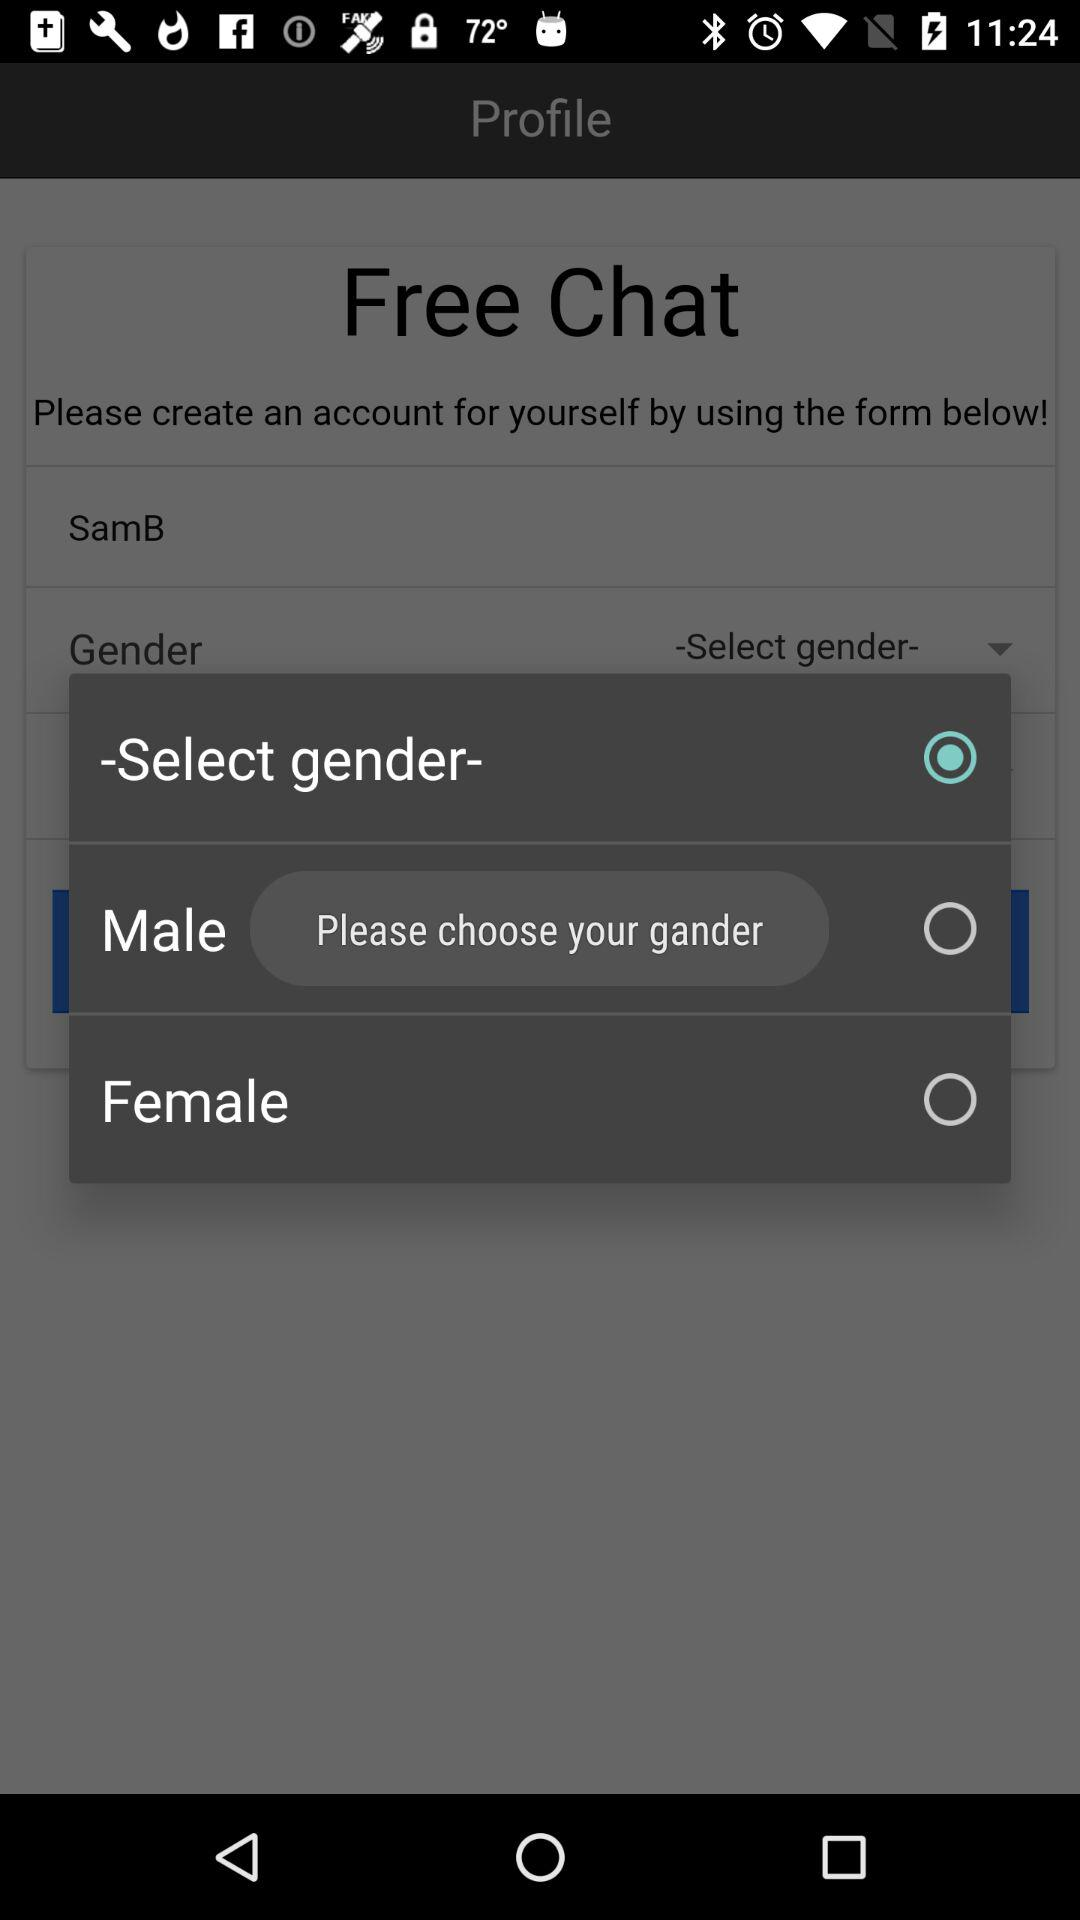Which option is selected? The selected option is "-Select gender-". 